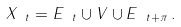<formula> <loc_0><loc_0><loc_500><loc_500>X _ { \ t } = E _ { \ t } \cup V \cup E _ { \ t + \pi } \, .</formula> 